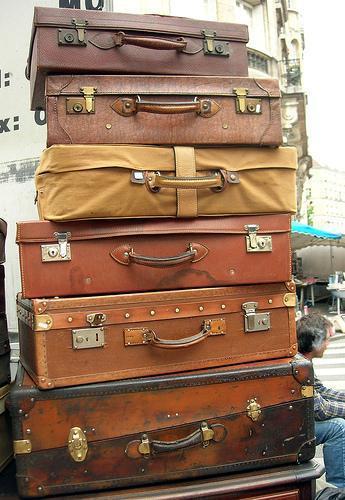How many suitcases are in focus?
Give a very brief answer. 6. 